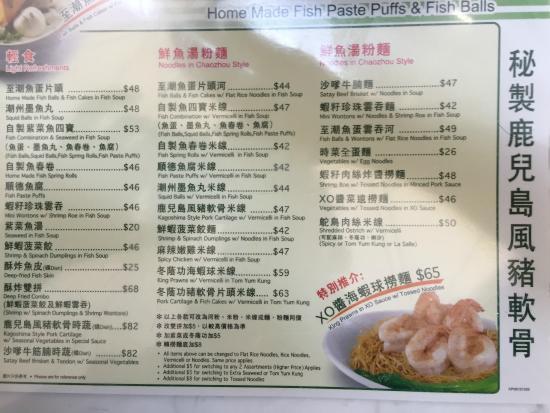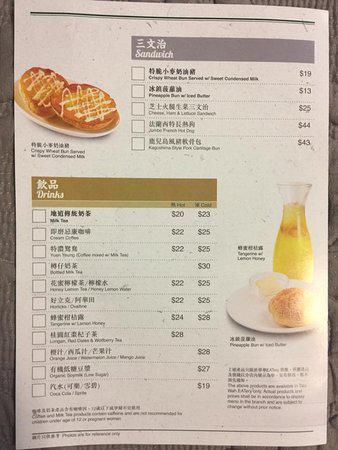The first image is the image on the left, the second image is the image on the right. Analyze the images presented: Is the assertion "One of the menus features over twenty pictures of the items." valid? Answer yes or no. No. The first image is the image on the left, the second image is the image on the right. For the images displayed, is the sentence "There are five lined menus in a row with pink headers." factually correct? Answer yes or no. No. 